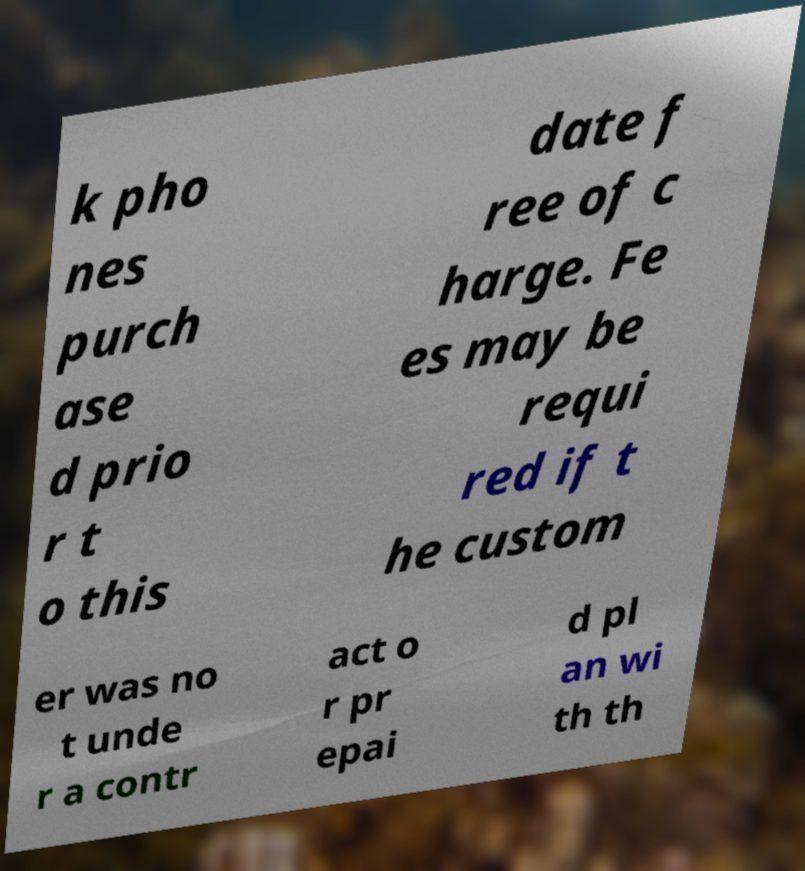For documentation purposes, I need the text within this image transcribed. Could you provide that? k pho nes purch ase d prio r t o this date f ree of c harge. Fe es may be requi red if t he custom er was no t unde r a contr act o r pr epai d pl an wi th th 